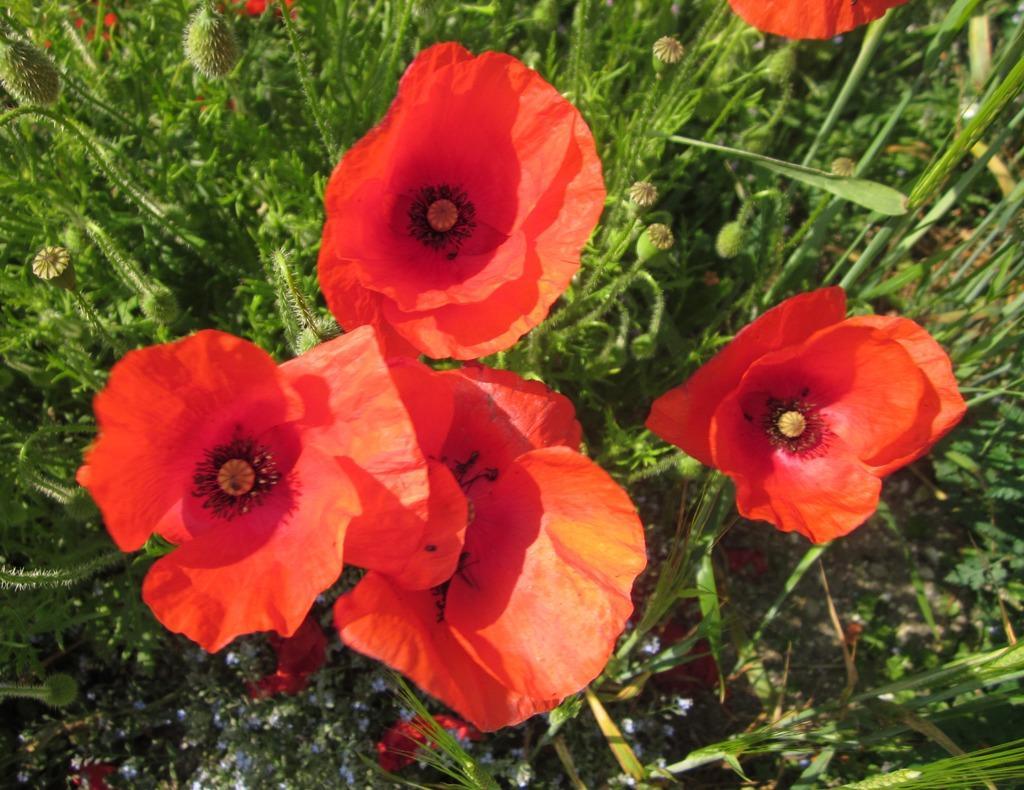Could you give a brief overview of what you see in this image? In this image there are flowers and there are plants. 